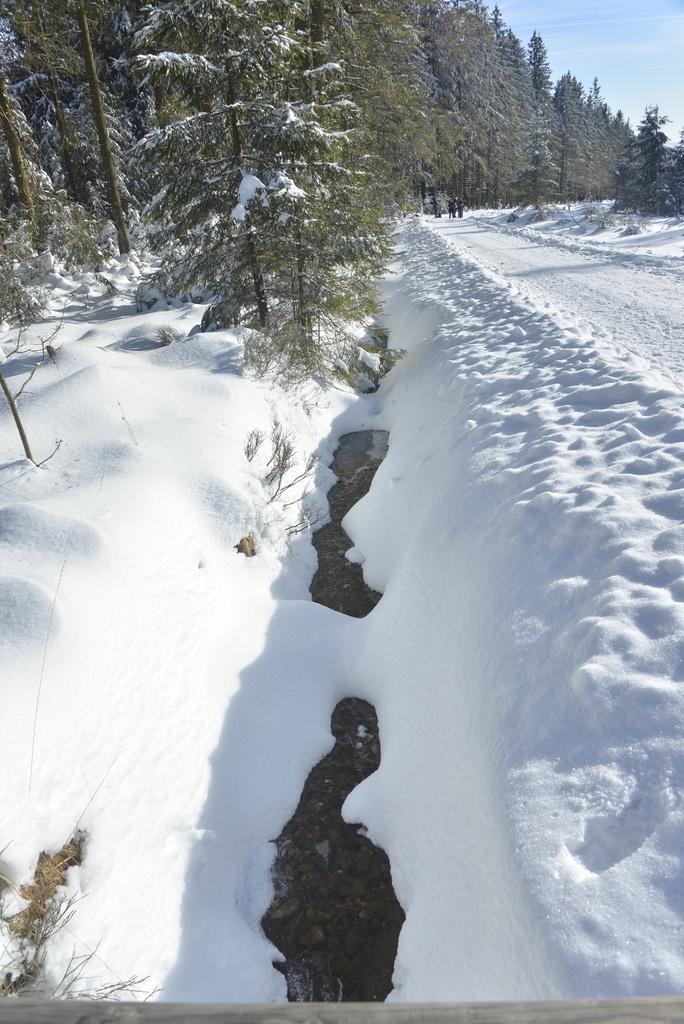Describe this image in one or two sentences. In this image I can see ice on the road, trees and group of people. On the right top I can see the sky. This image is taken during a sunny day. 